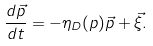Convert formula to latex. <formula><loc_0><loc_0><loc_500><loc_500>\frac { d \vec { p } } { d t } = - \eta _ { D } ( p ) \vec { p } + \vec { \xi } .</formula> 